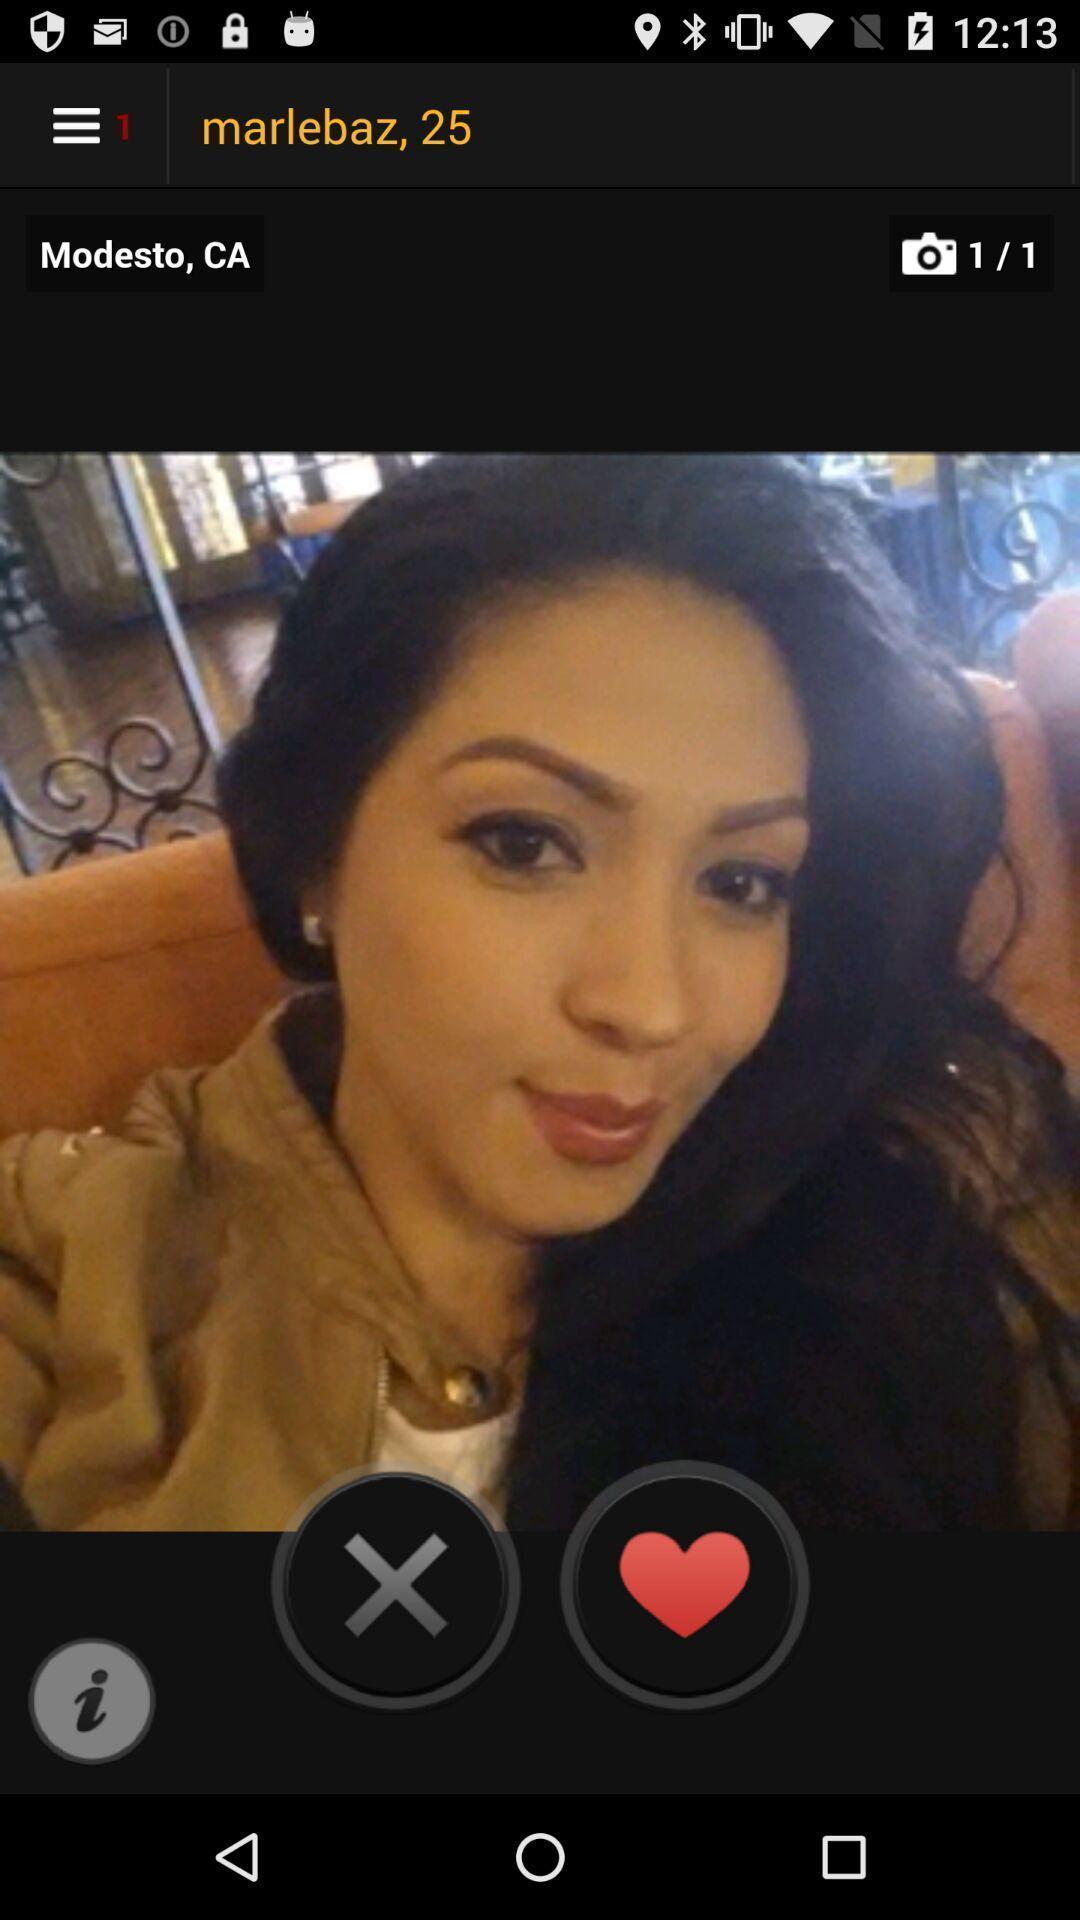Tell me what you see in this picture. Page showing a profile to like in a dating app. 